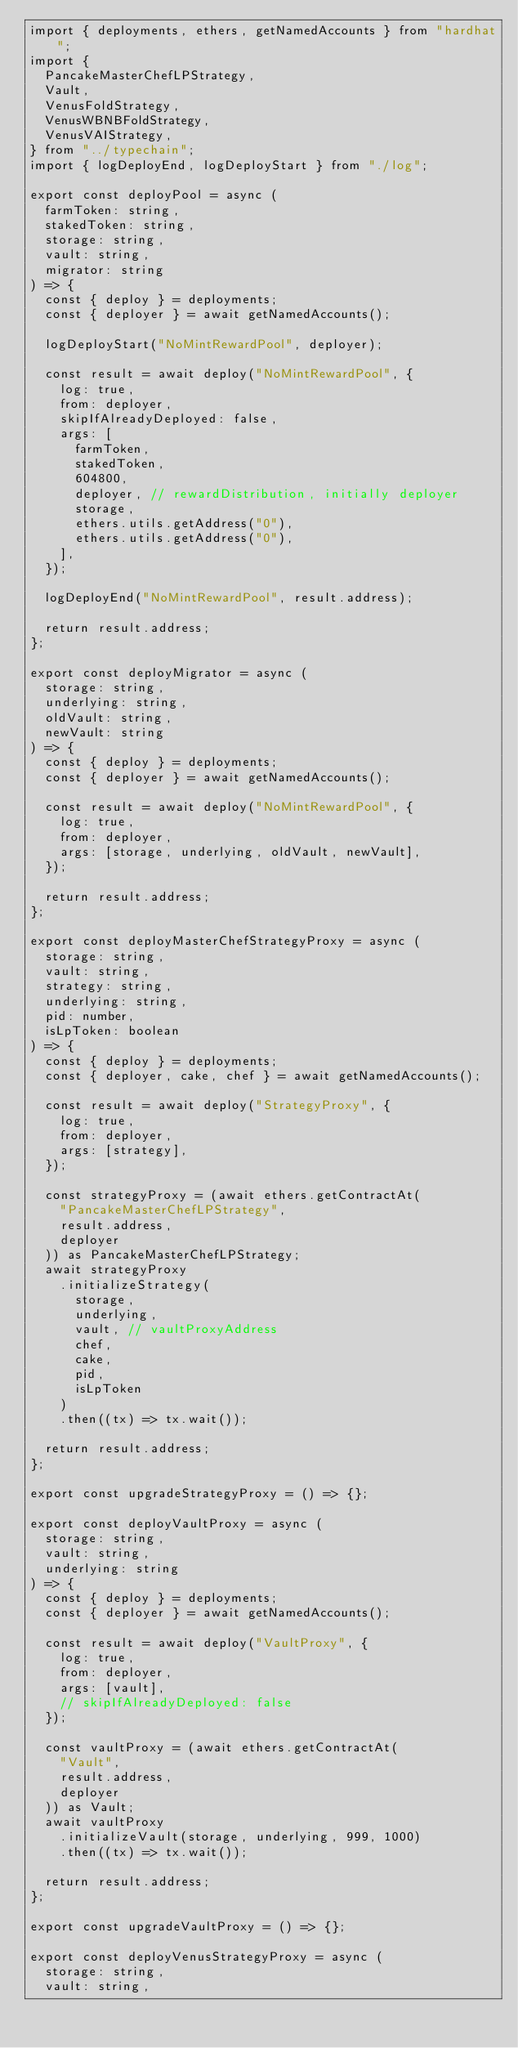Convert code to text. <code><loc_0><loc_0><loc_500><loc_500><_TypeScript_>import { deployments, ethers, getNamedAccounts } from "hardhat";
import {
  PancakeMasterChefLPStrategy,
  Vault,
  VenusFoldStrategy,
  VenusWBNBFoldStrategy,
  VenusVAIStrategy,
} from "../typechain";
import { logDeployEnd, logDeployStart } from "./log";

export const deployPool = async (
  farmToken: string,
  stakedToken: string,
  storage: string,
  vault: string,
  migrator: string
) => {
  const { deploy } = deployments;
  const { deployer } = await getNamedAccounts();

  logDeployStart("NoMintRewardPool", deployer);

  const result = await deploy("NoMintRewardPool", {
    log: true,
    from: deployer,
    skipIfAlreadyDeployed: false,
    args: [
      farmToken,
      stakedToken,
      604800,
      deployer, // rewardDistribution, initially deployer
      storage,
      ethers.utils.getAddress("0"),
      ethers.utils.getAddress("0"),
    ],
  });

  logDeployEnd("NoMintRewardPool", result.address);

  return result.address;
};

export const deployMigrator = async (
  storage: string,
  underlying: string,
  oldVault: string,
  newVault: string
) => {
  const { deploy } = deployments;
  const { deployer } = await getNamedAccounts();

  const result = await deploy("NoMintRewardPool", {
    log: true,
    from: deployer,
    args: [storage, underlying, oldVault, newVault],
  });

  return result.address;
};

export const deployMasterChefStrategyProxy = async (
  storage: string,
  vault: string,
  strategy: string,
  underlying: string,
  pid: number,
  isLpToken: boolean
) => {
  const { deploy } = deployments;
  const { deployer, cake, chef } = await getNamedAccounts();

  const result = await deploy("StrategyProxy", {
    log: true,
    from: deployer,
    args: [strategy],
  });

  const strategyProxy = (await ethers.getContractAt(
    "PancakeMasterChefLPStrategy",
    result.address,
    deployer
  )) as PancakeMasterChefLPStrategy;
  await strategyProxy
    .initializeStrategy(
      storage,
      underlying,
      vault, // vaultProxyAddress
      chef,
      cake,
      pid,
      isLpToken
    )
    .then((tx) => tx.wait());

  return result.address;
};

export const upgradeStrategyProxy = () => {};

export const deployVaultProxy = async (
  storage: string,
  vault: string,
  underlying: string
) => {
  const { deploy } = deployments;
  const { deployer } = await getNamedAccounts();

  const result = await deploy("VaultProxy", {
    log: true,
    from: deployer,
    args: [vault],
    // skipIfAlreadyDeployed: false
  });

  const vaultProxy = (await ethers.getContractAt(
    "Vault",
    result.address,
    deployer
  )) as Vault;
  await vaultProxy
    .initializeVault(storage, underlying, 999, 1000)
    .then((tx) => tx.wait());

  return result.address;
};

export const upgradeVaultProxy = () => {};

export const deployVenusStrategyProxy = async (
  storage: string,
  vault: string,</code> 